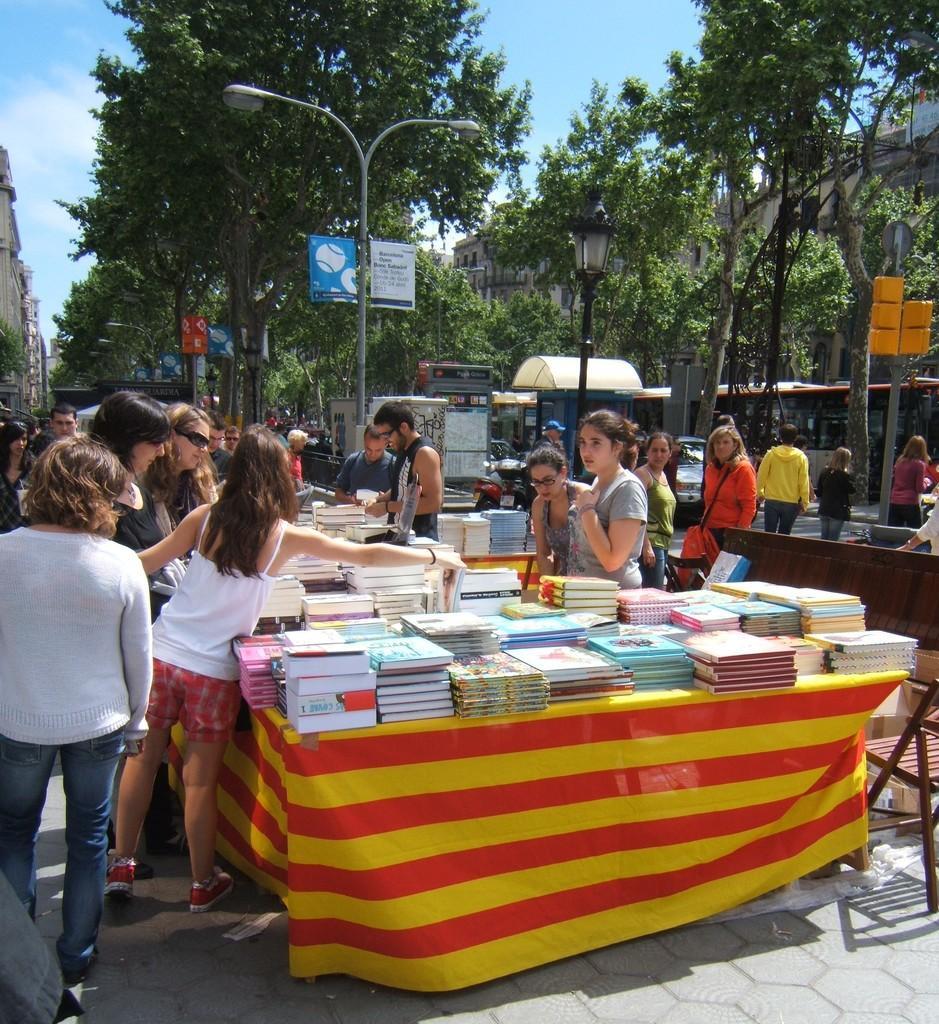How would you summarize this image in a sentence or two? In this image in the middle there is a table on that there are many books. On the left there is a woman, she wears a t shirt, trouser, in front of her there are some people. On the right there is a woman, she wears a t shirt and there are some people. In the background there are trees, street lights, posters, buildings, poles, sky and clouds. 